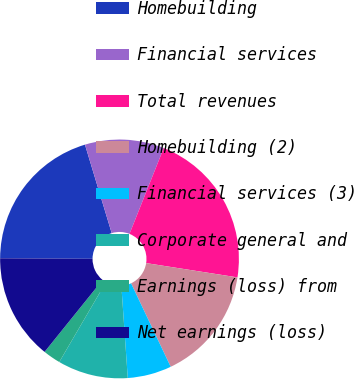<chart> <loc_0><loc_0><loc_500><loc_500><pie_chart><fcel>Homebuilding<fcel>Financial services<fcel>Total revenues<fcel>Homebuilding (2)<fcel>Financial services (3)<fcel>Corporate general and<fcel>Earnings (loss) from<fcel>Net earnings (loss)<nl><fcel>20.24%<fcel>10.71%<fcel>21.43%<fcel>15.48%<fcel>5.95%<fcel>9.52%<fcel>2.38%<fcel>14.29%<nl></chart> 